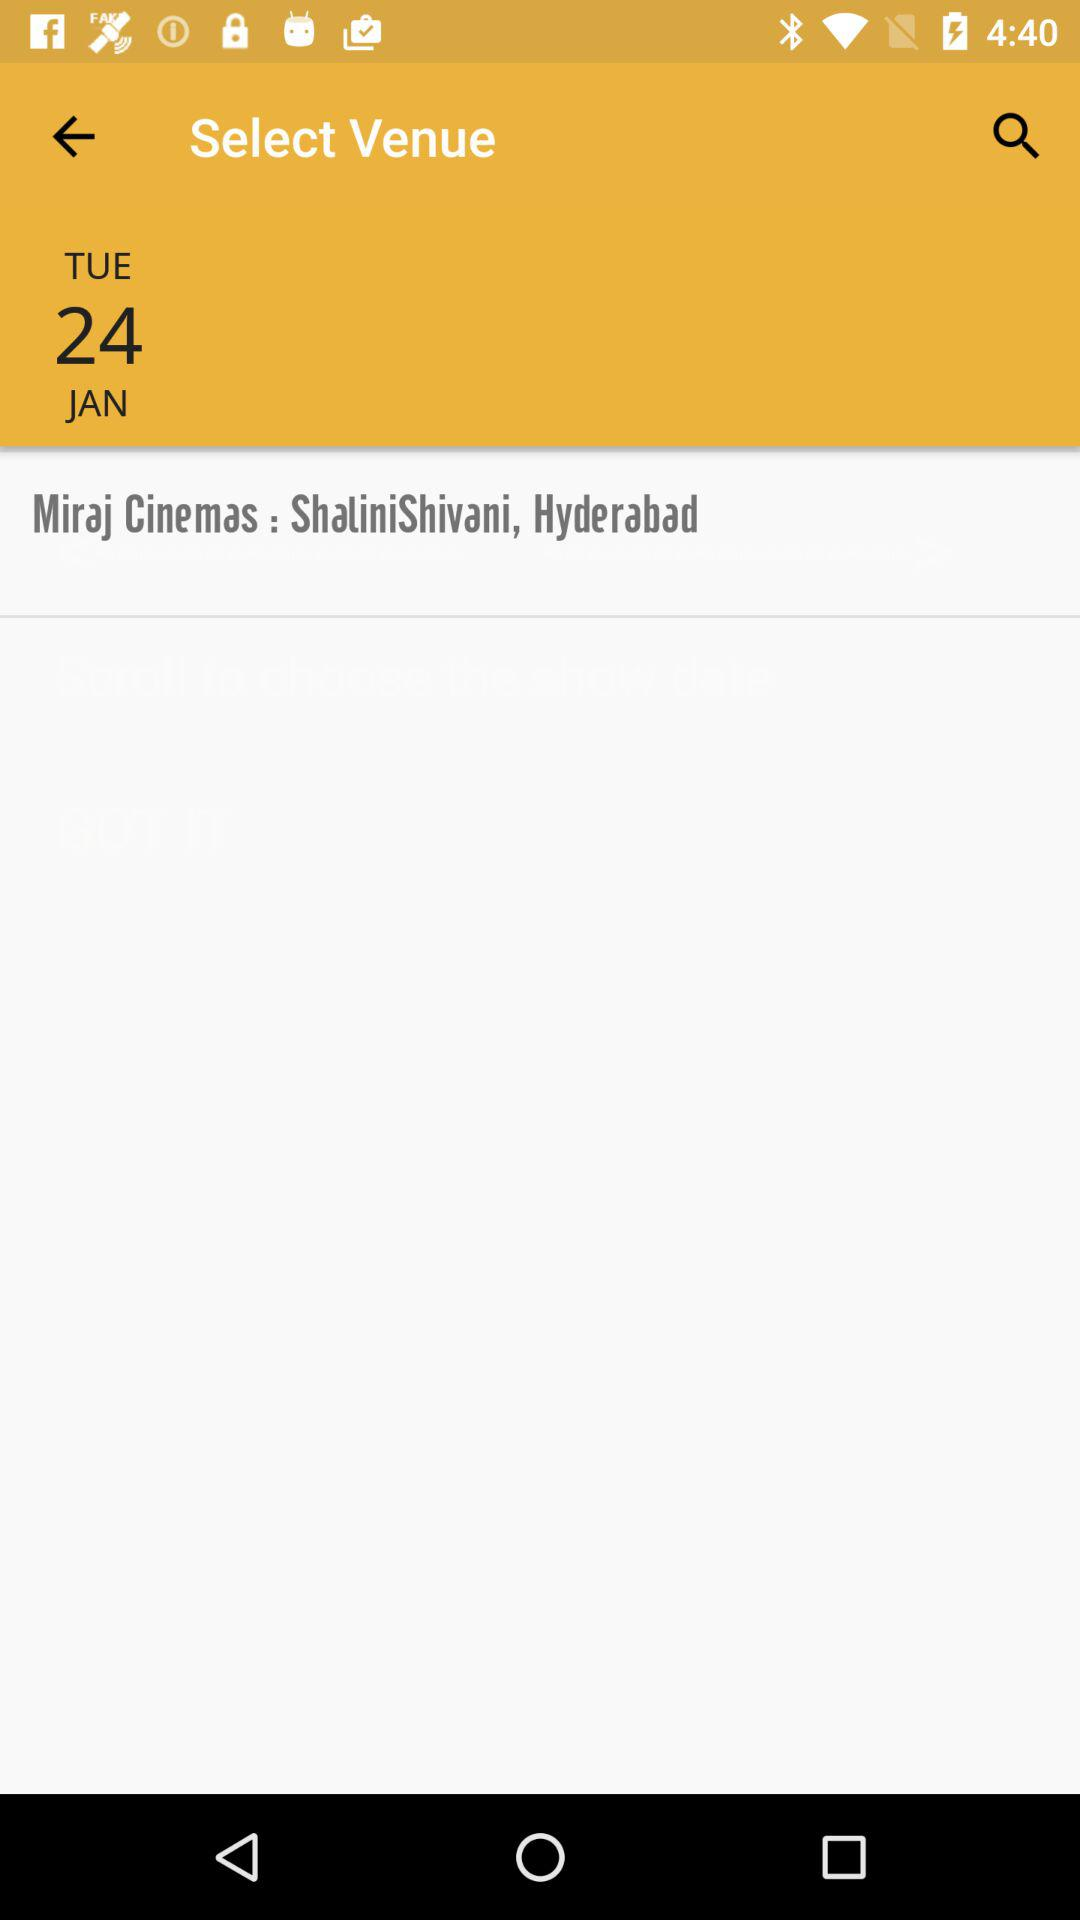What is the venue? The venue is "Miraj Cinemas : ShaliniShivani, Hyderabad". 